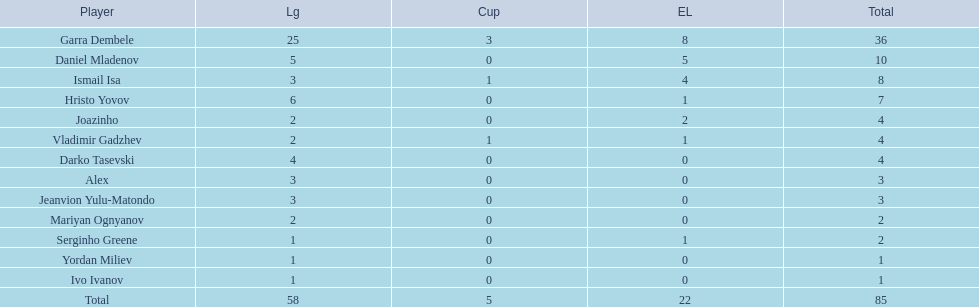What league is 2? 2, 2, 2. Which cup is less than 1? 0, 0. Which total is 2? 2. Who is the player? Mariyan Ognyanov. 